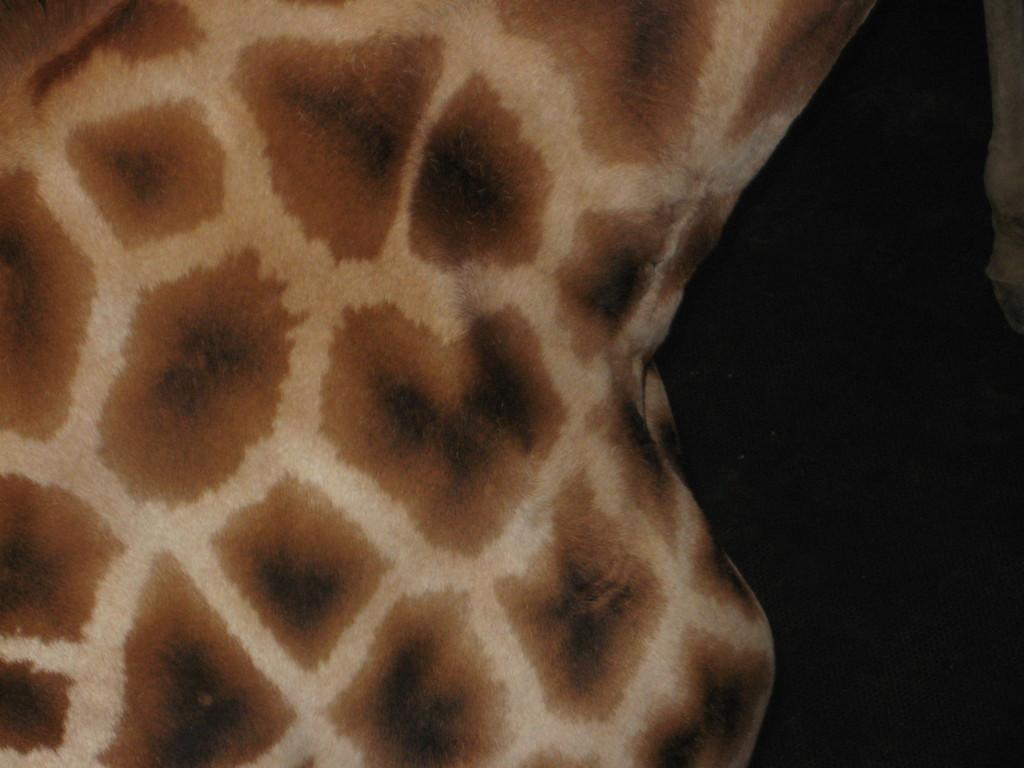What type of print is featured in the image? There is a giraffe print in the image. What color is the background of the image? The background of the image is black. Can you see any volcanoes erupting in the image? There are no volcanoes present in the image. What type of memory is depicted in the image? There is no memory depicted in the image; it features a giraffe print and a black background. 